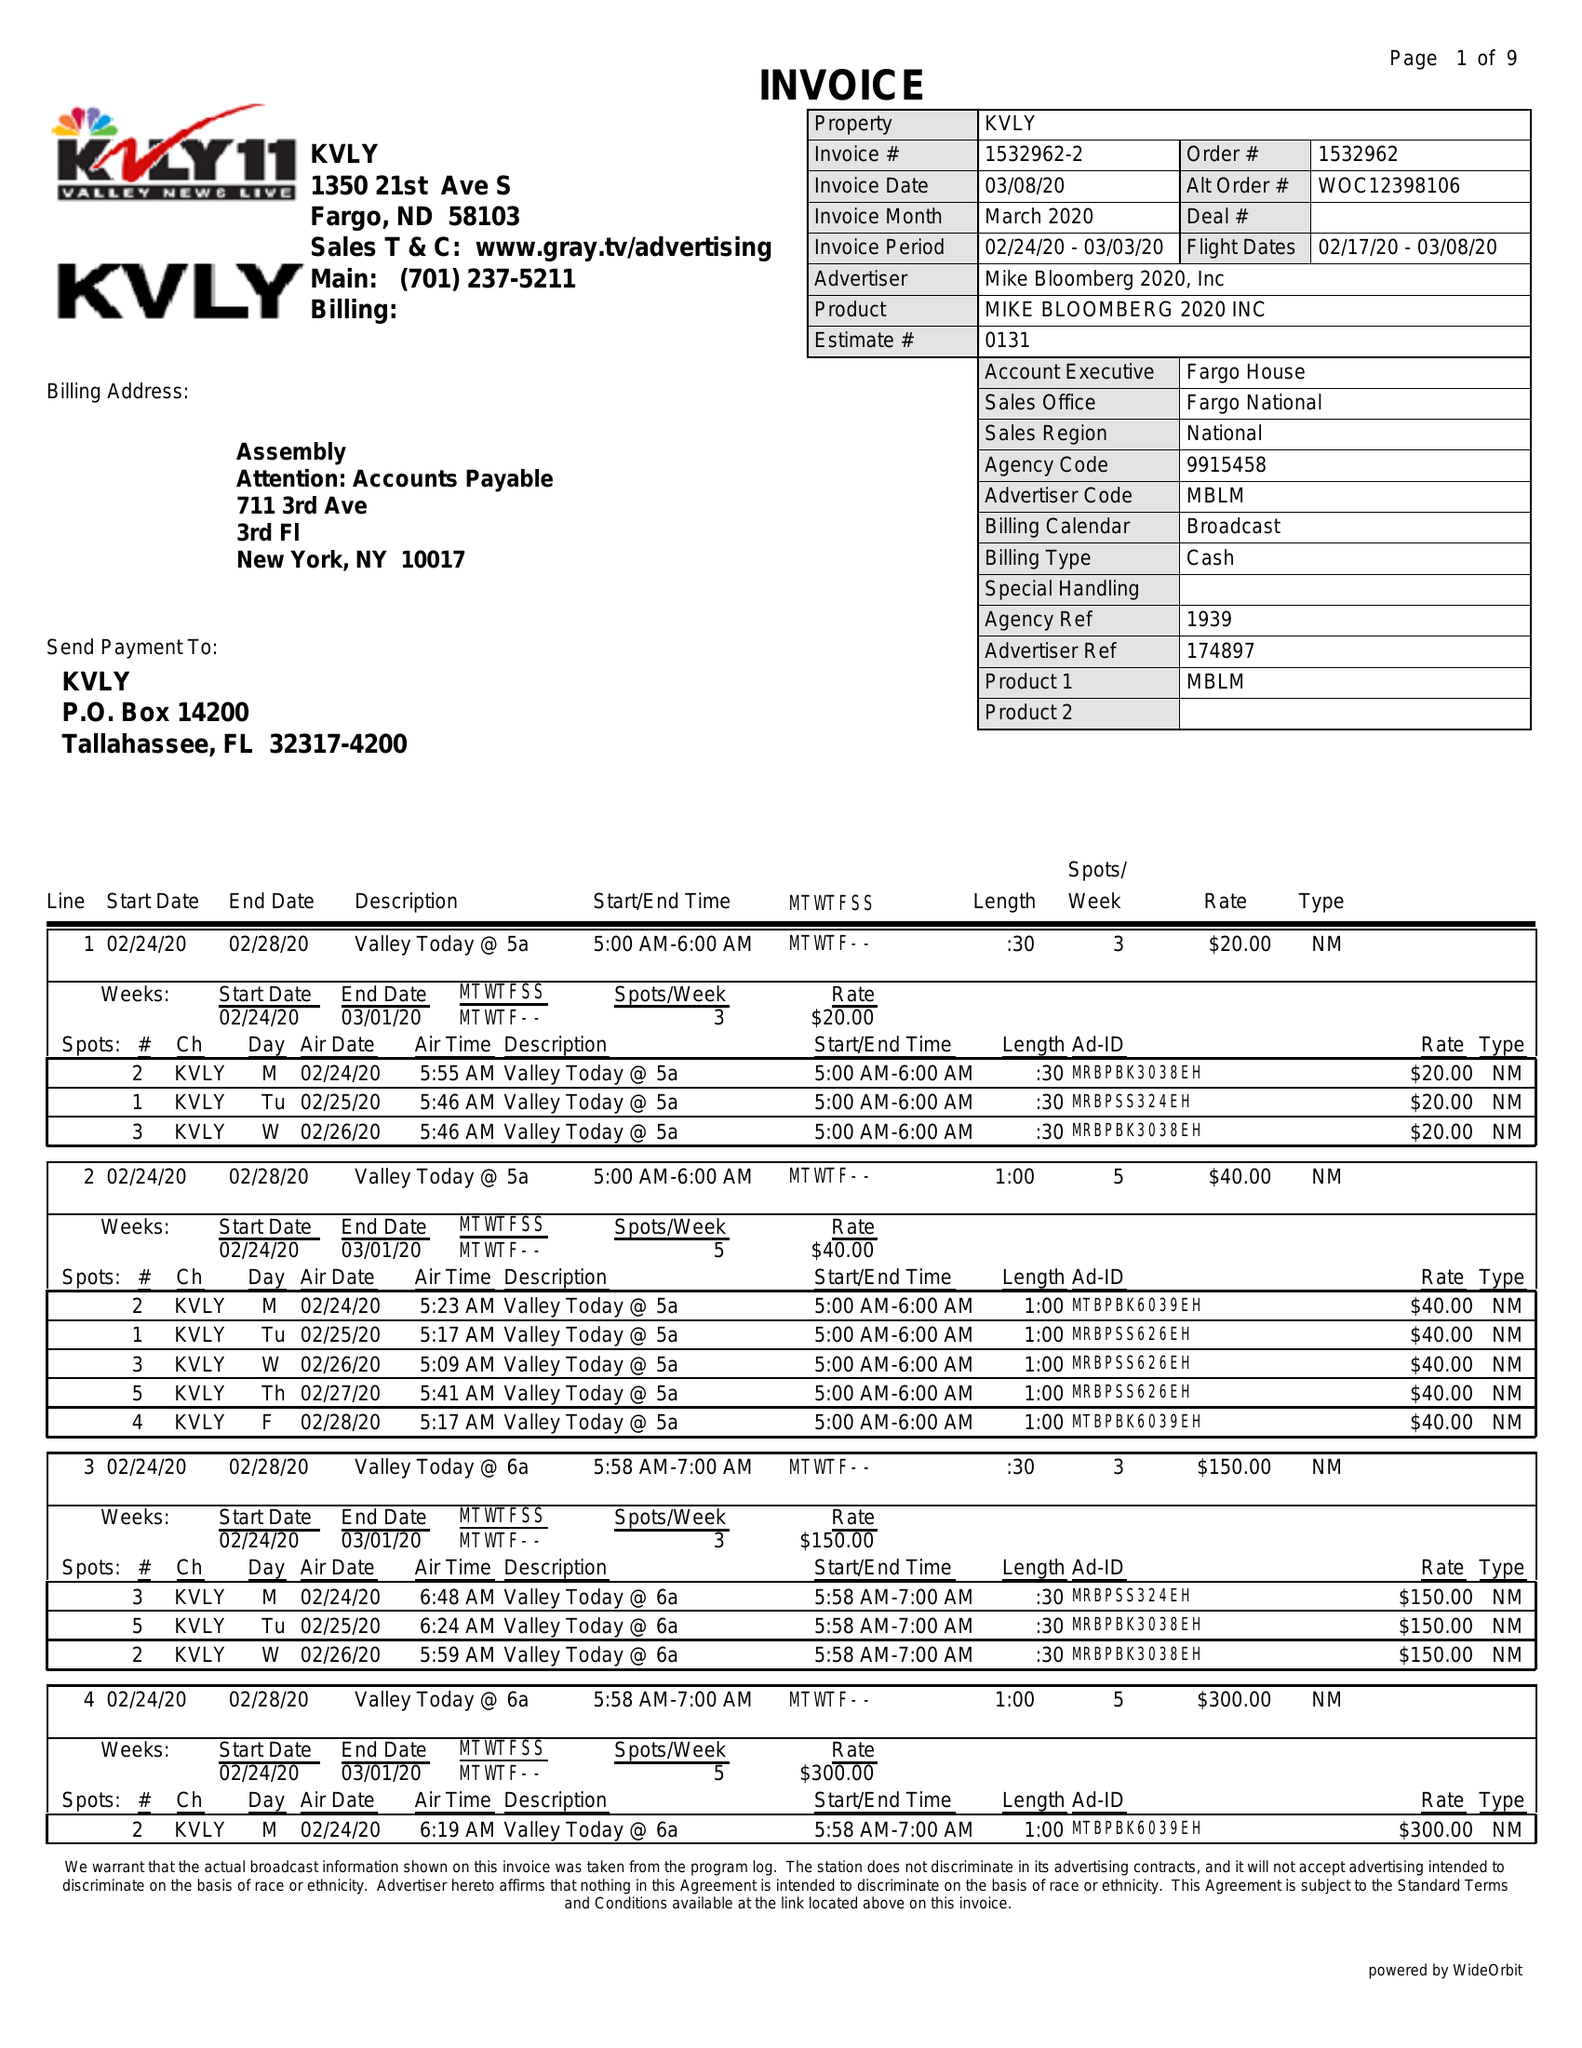What is the value for the gross_amount?
Answer the question using a single word or phrase. 17560.00 